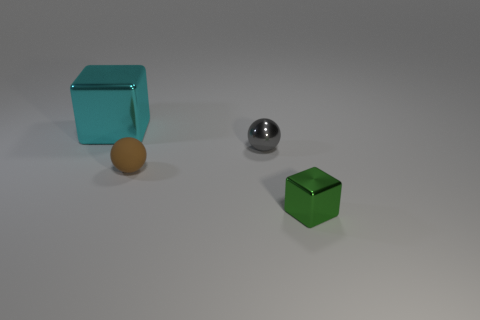Add 4 small blocks. How many objects exist? 8 Subtract all gray balls. How many balls are left? 1 Subtract 1 cubes. How many cubes are left? 1 Subtract all green cylinders. How many brown spheres are left? 1 Subtract all blue matte objects. Subtract all metal blocks. How many objects are left? 2 Add 4 green metal blocks. How many green metal blocks are left? 5 Add 4 big purple shiny balls. How many big purple shiny balls exist? 4 Subtract 1 cyan cubes. How many objects are left? 3 Subtract all gray blocks. Subtract all gray cylinders. How many blocks are left? 2 